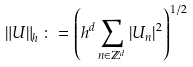<formula> <loc_0><loc_0><loc_500><loc_500>\left \| U \right \| _ { h } \colon = \left ( h ^ { d } \sum _ { n \in \mathbb { Z } ^ { d } } \left | U _ { n } \right | ^ { 2 } \right ) ^ { 1 / 2 }</formula> 